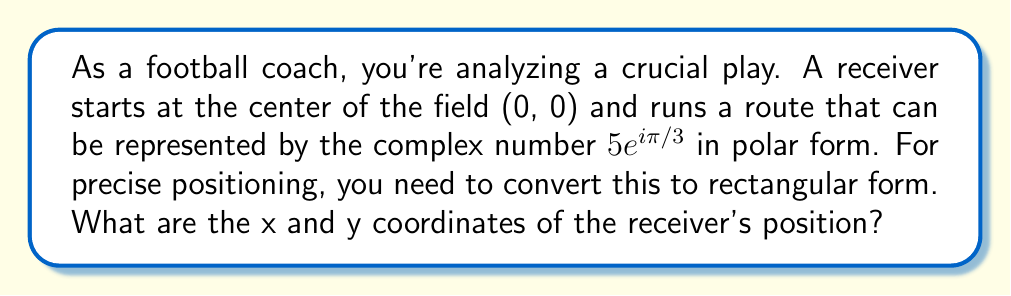Could you help me with this problem? To solve this problem, we need to convert the complex number from polar form to rectangular form. The general formula for this conversion is:

$$ z = re^{i\theta} = r(\cos\theta + i\sin\theta) $$

Where:
- $r$ is the magnitude (distance from the origin)
- $\theta$ is the angle in radians
- The real part represents the x-coordinate
- The imaginary part represents the y-coordinate

Given:
$$ z = 5e^{i\pi/3} $$

Step 1: Identify $r$ and $\theta$
$r = 5$
$\theta = \pi/3$

Step 2: Apply the conversion formula
$$ z = 5(\cos(\pi/3) + i\sin(\pi/3)) $$

Step 3: Calculate $\cos(\pi/3)$ and $\sin(\pi/3)$
$\cos(\pi/3) = 1/2$
$\sin(\pi/3) = \sqrt{3}/2$

Step 4: Substitute these values
$$ z = 5(1/2 + i\sqrt{3}/2) $$

Step 5: Simplify
$$ z = 5/2 + i5\sqrt{3}/2 $$

The real part (x-coordinate) is $5/2 = 2.5$
The imaginary part (y-coordinate) is $5\sqrt{3}/2 \approx 4.33$

Therefore, the receiver's position in rectangular coordinates is approximately (2.5, 4.33).
Answer: The receiver's position in rectangular coordinates is $(2.5, 4.33)$. 